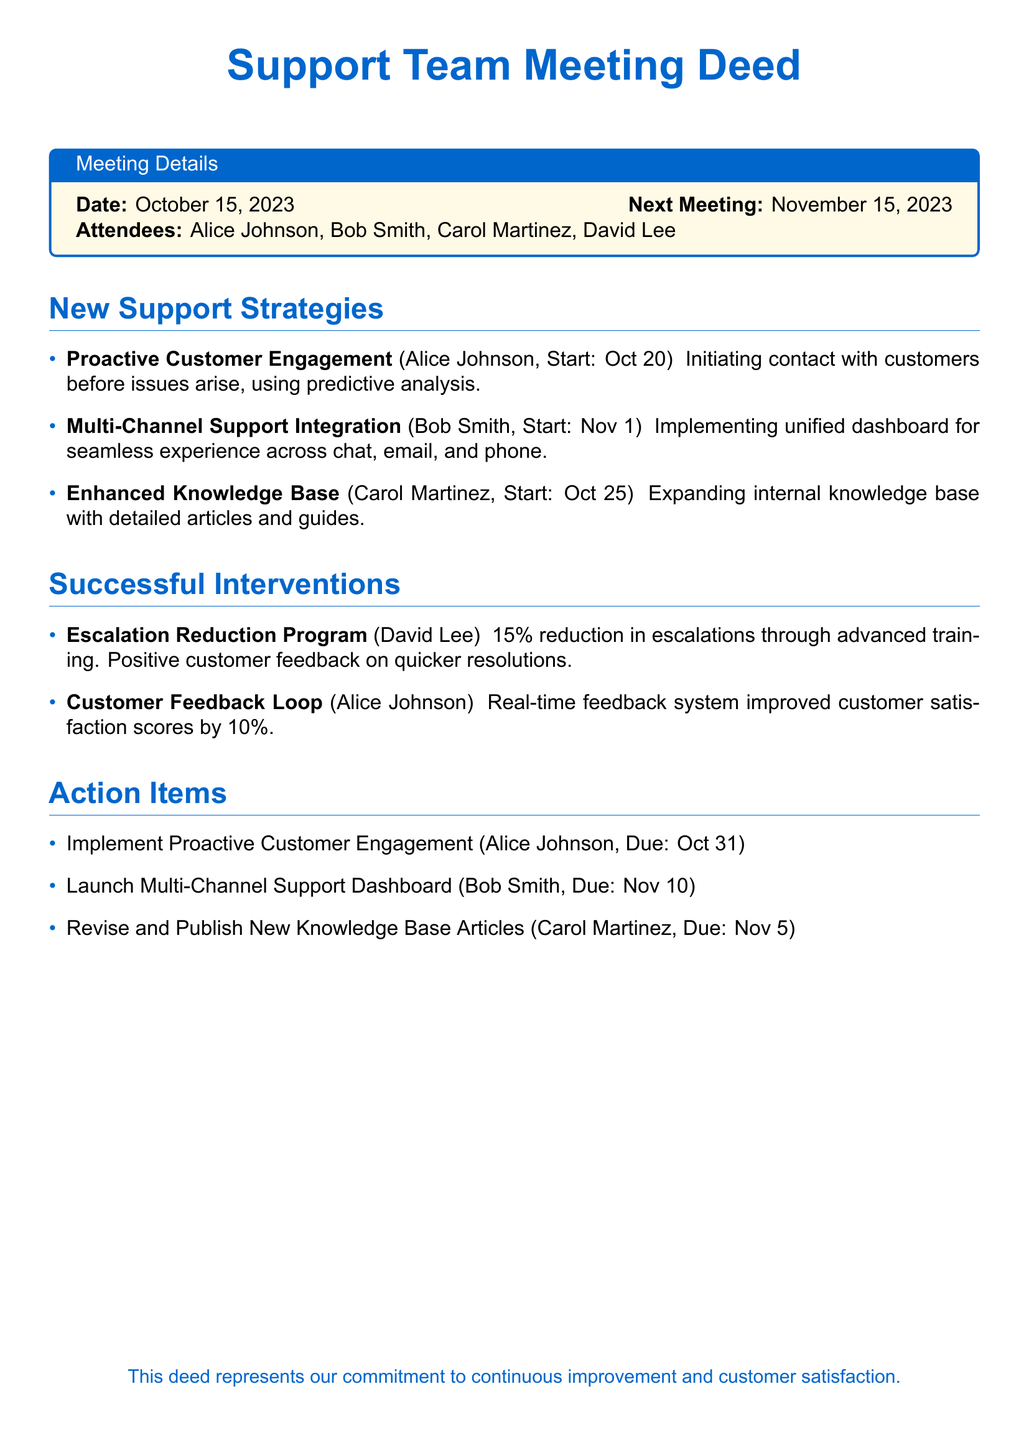What is the date of the meeting? The date of the meeting is explicitly stated at the beginning of the document.
Answer: October 15, 2023 Who initiated the Proactive Customer Engagement strategy? The document lists Alice Johnson as the person responsible for this strategy.
Answer: Alice Johnson What is the start date for the Enhanced Knowledge Base strategy? The start date for this strategy is specified in the document next to the description.
Answer: October 25 How much did the Escalation Reduction Program reduce escalations by? The percentage reduction in escalations is mentioned in the section on successful interventions.
Answer: 15% What is the due date for launching the Multi-Channel Support Dashboard? The due date is clearly indicated next to the respective action item in the document.
Answer: November 10 Which strategy aims to improve customer satisfaction scores by 10%? The document specifies that the Customer Feedback Loop aims to achieve this goal.
Answer: Customer Feedback Loop What is the next meeting date? The next meeting's date is provided at the beginning of the document.
Answer: November 15, 2023 Who is responsible for revising and publishing new knowledge base articles? Carol Martinez is identified as the person responsible for this action item in the document.
Answer: Carol Martinez What is the primary color theme used in the document? The document's title and headings indicate a consistent theme color.
Answer: Blue 